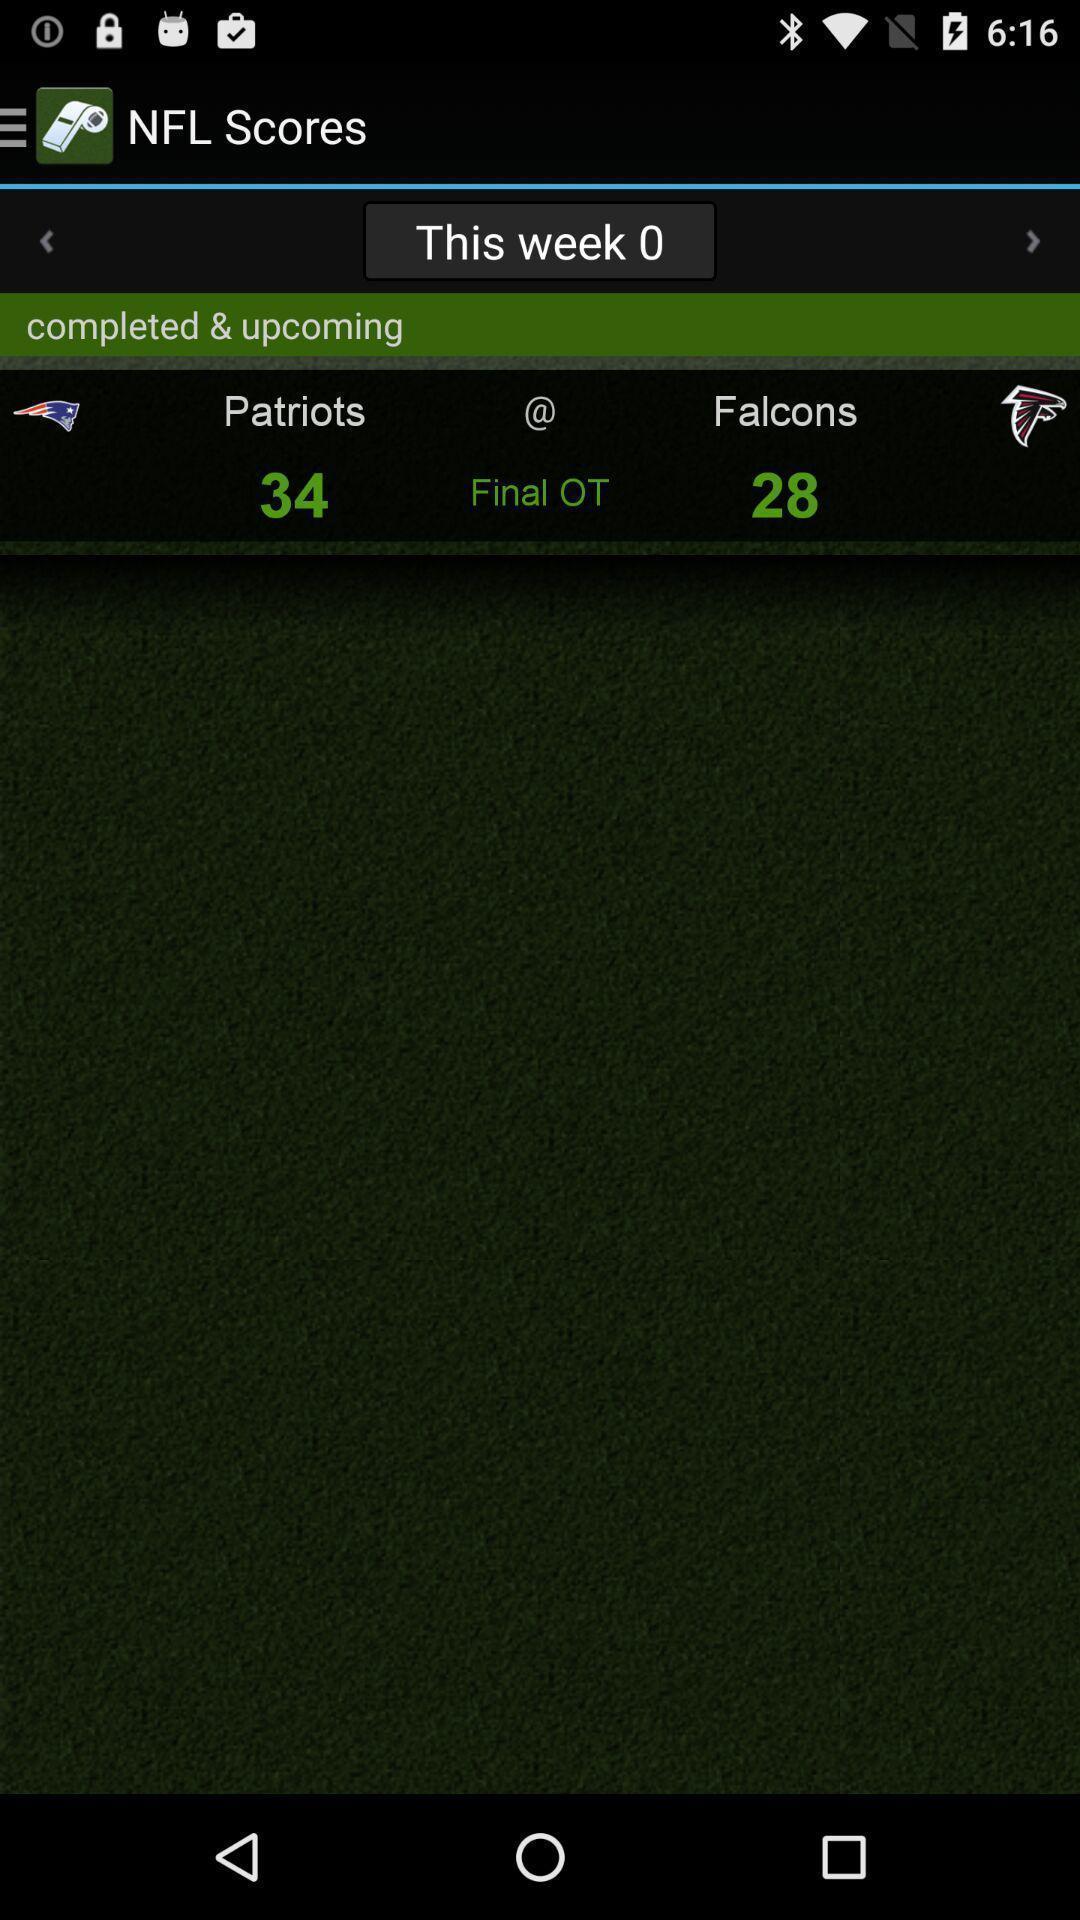Describe the content in this image. Screen showing few scores on completed games. 